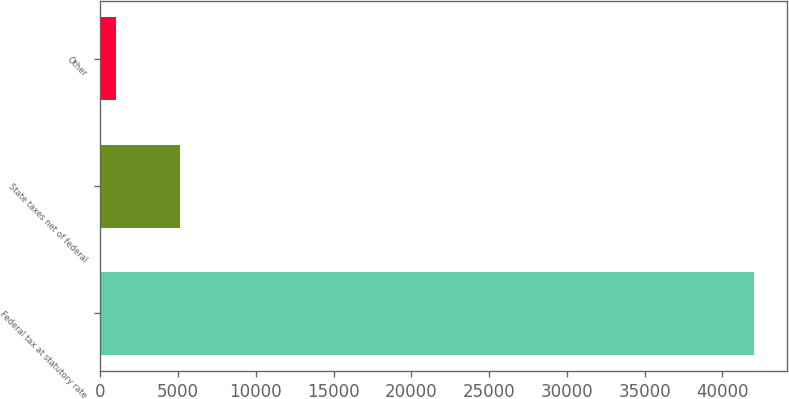Convert chart to OTSL. <chart><loc_0><loc_0><loc_500><loc_500><bar_chart><fcel>Federal tax at statutory rate<fcel>State taxes net of federal<fcel>Other<nl><fcel>42048<fcel>5138.1<fcel>1037<nl></chart> 